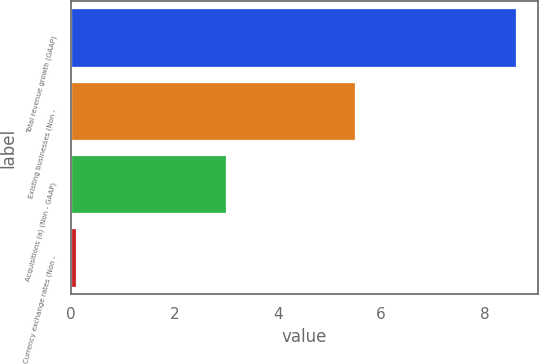<chart> <loc_0><loc_0><loc_500><loc_500><bar_chart><fcel>Total revenue growth (GAAP)<fcel>Existing businesses (Non -<fcel>Acquisitions (a) (Non - GAAP)<fcel>Currency exchange rates (Non -<nl><fcel>8.6<fcel>5.5<fcel>3<fcel>0.1<nl></chart> 